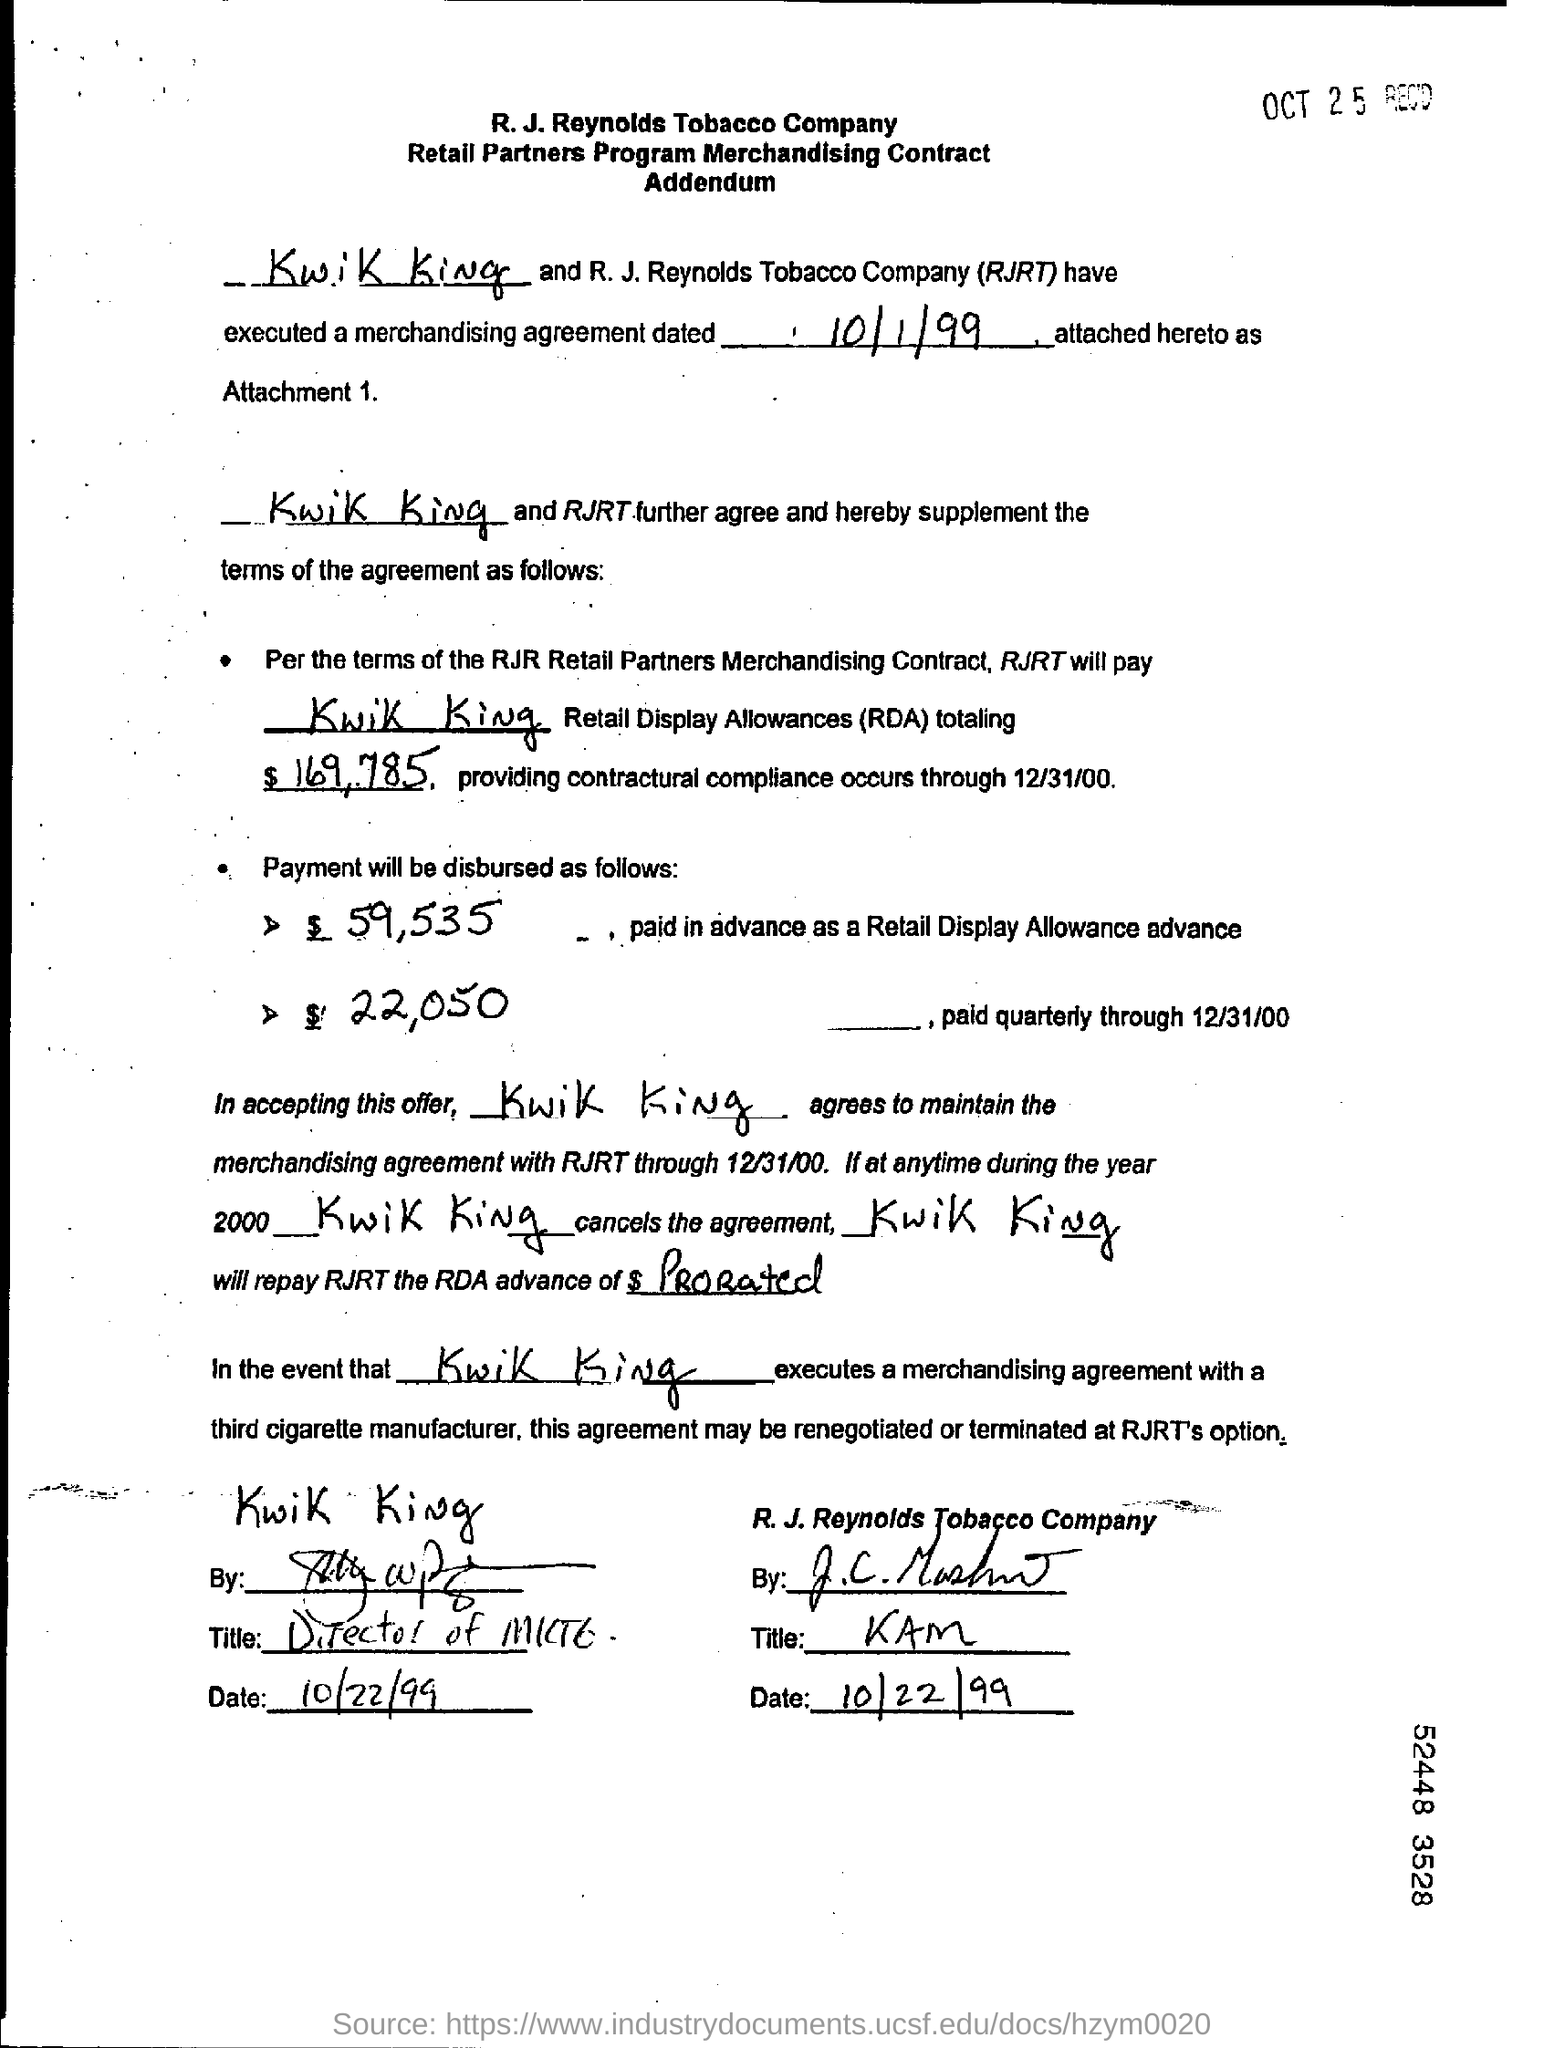Indicate a few pertinent items in this graphic. The quarterly payment made through 12/31/2000 was $22,050. The payment for a Retail Display Allowance advance is $59,535. It is agreed to maintain the merchandising agreement with RJRT through December 31, 2000. It is determined that RJRT will compensate Kwik King for the services provided. The total retail display allowances is $169,785. 